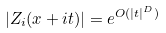<formula> <loc_0><loc_0><loc_500><loc_500>| Z _ { i } ( x + i t ) | = e ^ { O ( | t | ^ { D } ) }</formula> 